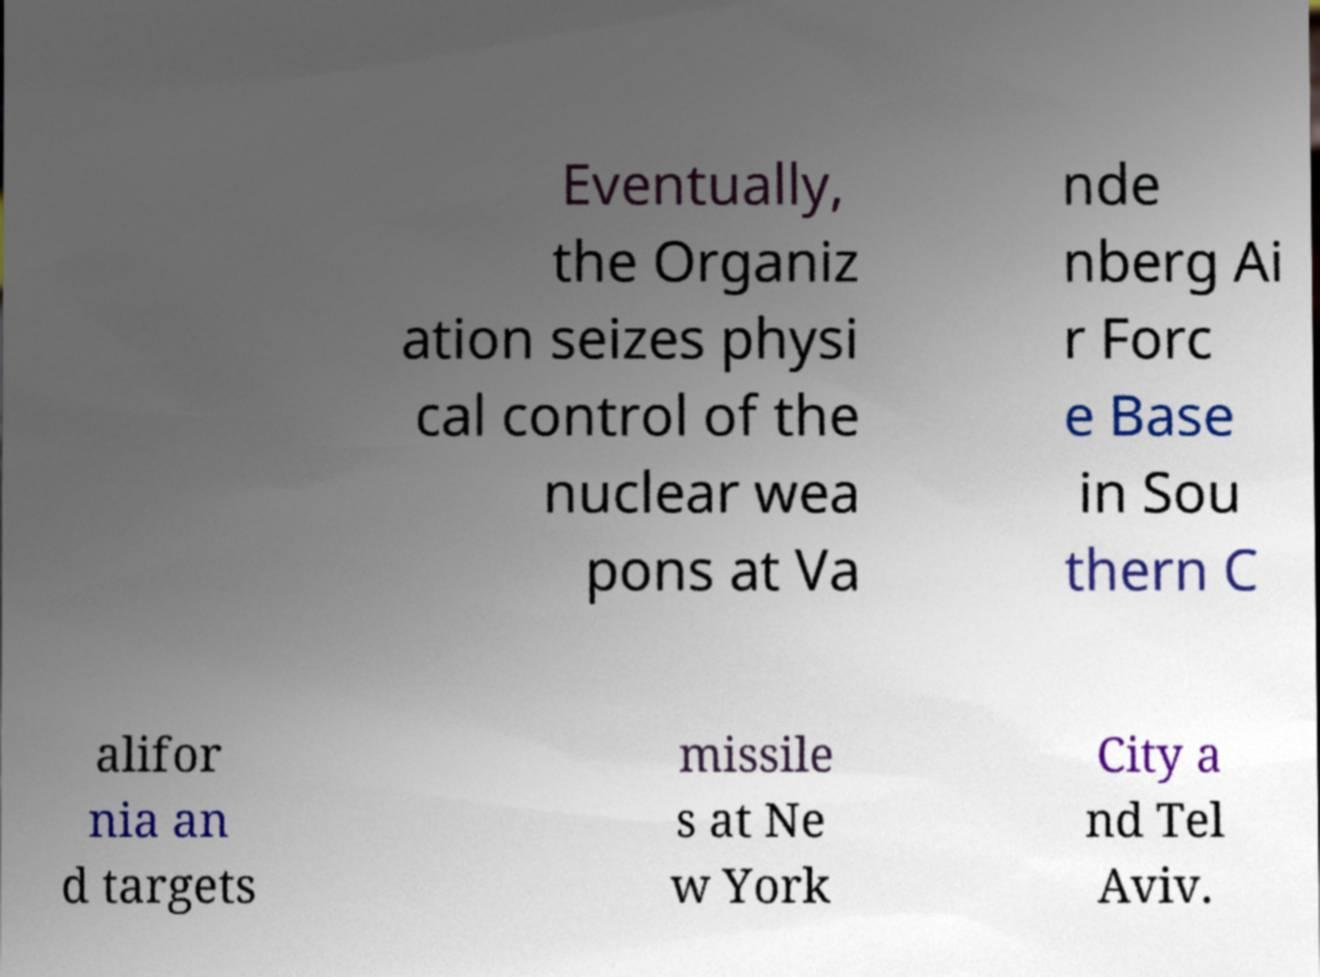There's text embedded in this image that I need extracted. Can you transcribe it verbatim? Eventually, the Organiz ation seizes physi cal control of the nuclear wea pons at Va nde nberg Ai r Forc e Base in Sou thern C alifor nia an d targets missile s at Ne w York City a nd Tel Aviv. 